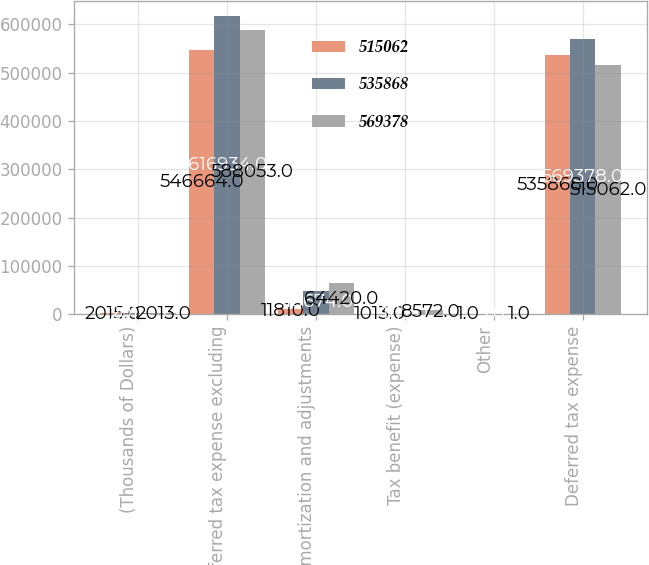Convert chart to OTSL. <chart><loc_0><loc_0><loc_500><loc_500><stacked_bar_chart><ecel><fcel>(Thousands of Dollars)<fcel>Deferred tax expense excluding<fcel>Amortization and adjustments<fcel>Tax benefit (expense)<fcel>Other<fcel>Deferred tax expense<nl><fcel>515062<fcel>2015<fcel>546664<fcel>11810<fcel>1013<fcel>1<fcel>535868<nl><fcel>535868<fcel>2014<fcel>616934<fcel>48674<fcel>1117<fcel>1<fcel>569378<nl><fcel>569378<fcel>2013<fcel>588053<fcel>64420<fcel>8572<fcel>1<fcel>515062<nl></chart> 